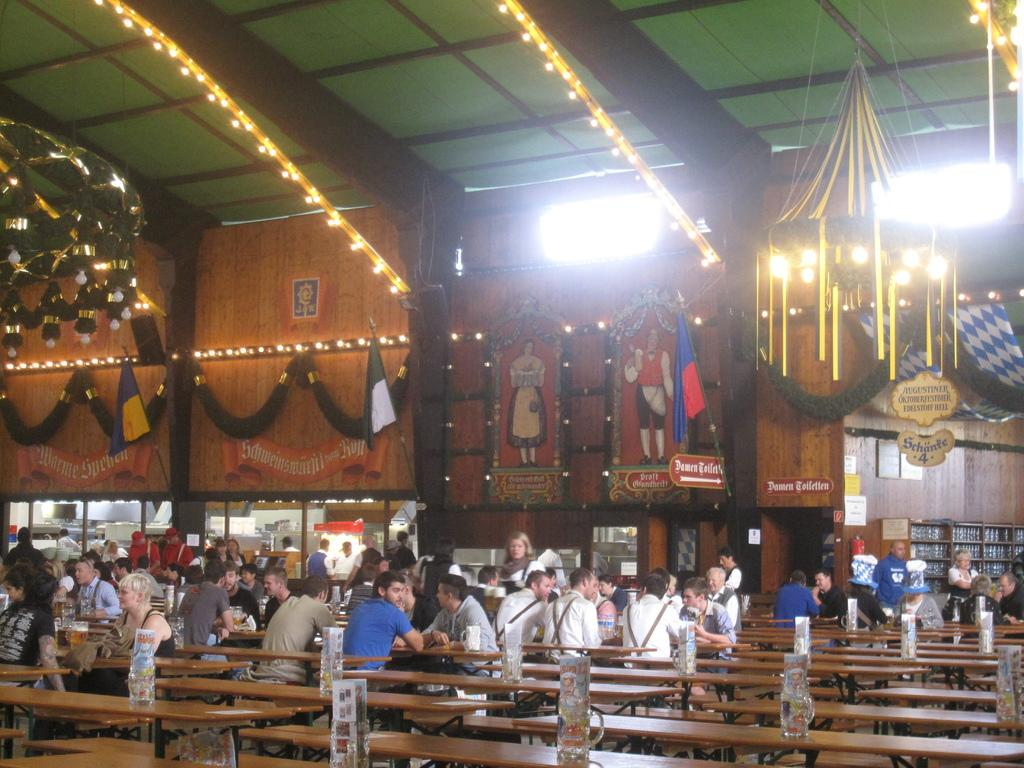What type of furniture is present in the image? There are tables and chairs in the image. What else can be seen in the image besides furniture? There are people and posters in the middle of the image. What is located at the top of the image? There are lights at the top of the image. Can you see any wounds on the people in the image? There is no mention of any wounds on the people in the image, so we cannot determine if any are present. What type of mint is being used as a decoration in the image? There is no mention of mint in the image, so we cannot determine if it is being used as a decoration. 